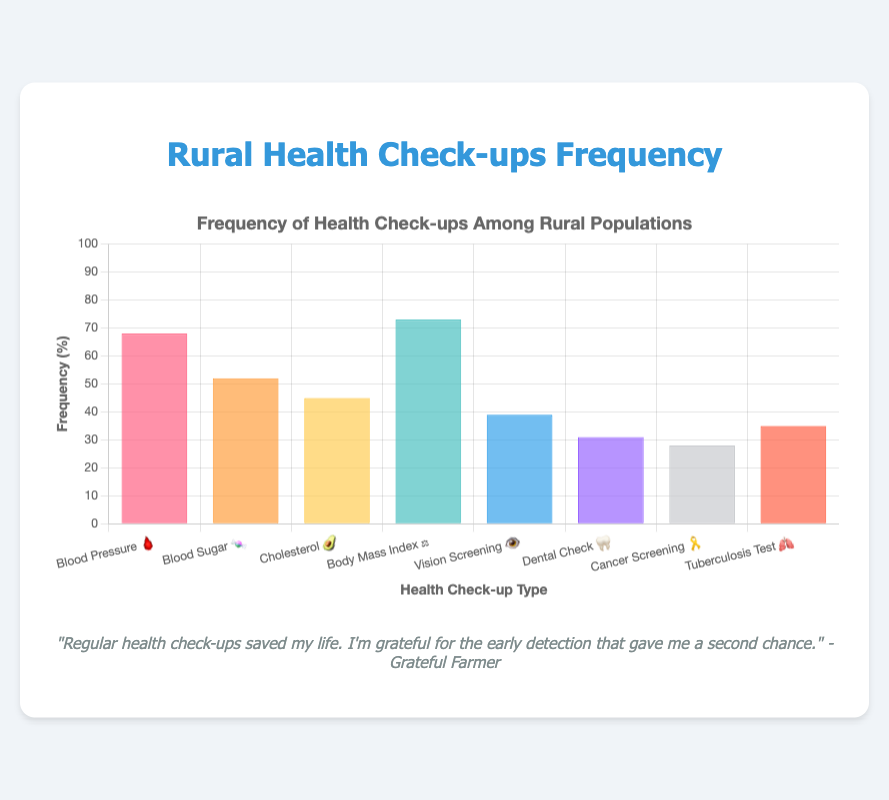What is the frequency of Blood Pressure check-ups? The frequency of Blood Pressure check-ups is indicated by the height of the bar labeled "Blood Pressure 🩸." The value is 68%.
Answer: 68% Which health check-up type has the highest frequency? By comparing the heights of all bars, the "Body Mass Index ⚖️" bar is the tallest. The frequency is 73%.
Answer: Body Mass Index ⚖️ Which two health check-up types have a frequency higher than 50%? By observing the bars taller than 50%, "Blood Pressure 🩸" with 68%, "Blood Sugar 🍬" with 52%, and "Body Mass Index ⚖️" with 73% are higher than 50%.
Answer: Blood Pressure 🩸 and Body Mass Index ⚖️ What is the total frequency percentage of Vision Screening and Dental Check? Add the frequency percentages of "Vision Screening 👁️" and "Dental Check 🦷," (39% + 31% = 70%). The total frequency is 70%.
Answer: 70% Which health check-up type has the lowest frequency? By comparing the heights of all bars, "Cancer Screening 🎗️" is the shortest with a frequency of 28%.
Answer: Cancer Screening 🎗️ How much higher is the frequency of Blood Pressure check-ups compared to Cancer Screening? Subtract the frequency of "Cancer Screening 🎗️" (28%) from "Blood Pressure 🩸" (68%) (68% - 28% = 40%). The difference is 40%.
Answer: 40% How many health check-up types have a frequency less than 50%? Observe the bars that are below the 50% mark. "Cholesterol 🥑" (45%), "Vision Screening 👁️" (39%), "Dental Check 🦷" (31%), "Cancer Screening 🎗️" (28%), and "Tuberculosis Test 🫁" (35%) have frequencies less than 50%. There are five.
Answer: 5 Which health check-up type has a frequency closest to the average frequency of all check-up types? Calculate the average frequency by adding all percentages and dividing by the number of categories ((68+52+45+73+39+31+28+35)/8 = 46.375%). Closest to this average is "Cholesterol 🥑" with 45%.
Answer: Cholesterol 🥑 